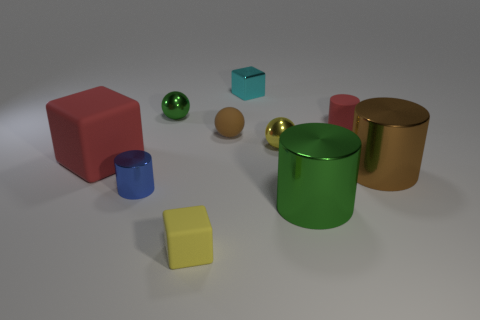What is the size of the green cylinder that is made of the same material as the large brown cylinder?
Provide a short and direct response. Large. Is there anything else of the same color as the rubber cylinder?
Provide a succinct answer. Yes. There is a green metal object that is in front of the tiny red rubber cylinder; what shape is it?
Provide a succinct answer. Cylinder. There is a tiny matte block; is it the same color as the small sphere in front of the brown matte sphere?
Give a very brief answer. Yes. Are there the same number of cubes that are in front of the brown rubber ball and tiny yellow objects that are right of the tiny cyan cube?
Your answer should be compact. No. How many other things are the same size as the green ball?
Give a very brief answer. 6. The red rubber cylinder is what size?
Keep it short and to the point. Small. Is the material of the red block the same as the red object that is right of the yellow cube?
Offer a very short reply. Yes. Is there a small yellow shiny object of the same shape as the small green thing?
Your answer should be very brief. Yes. What material is the cyan cube that is the same size as the green ball?
Make the answer very short. Metal. 